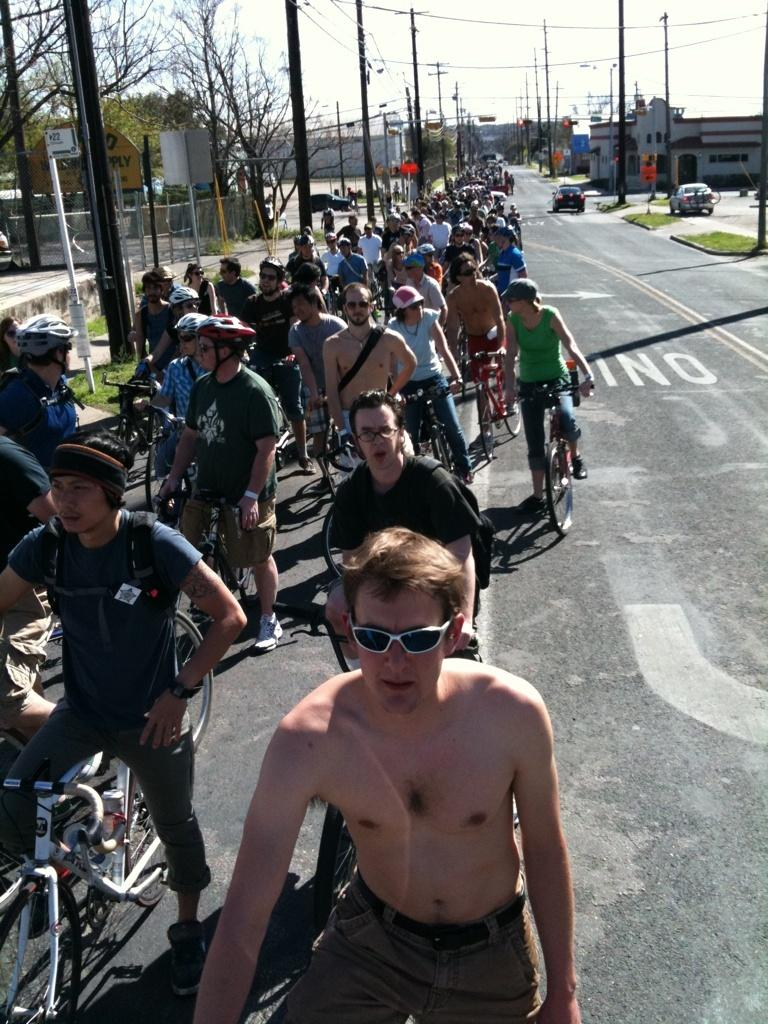How many people are in the image? There are people in the image, but the exact number is not specified. What are the people doing in the image? The people are standing and holding cycles in the image. What protective gear are the people wearing? The people are wearing goggles and helmets in the image. Where are the people standing? The people are standing on roads in the image. What can be seen in the background of the image? In the background of the image, there are cars, buildings, street lights, poles, and trees. What type of muscle is being flexed by the person in the image? There is no indication in the image that a person is flexing any muscles. What color is the yarn being used by the person in the image? There is no yarn present in the image. How many pears are visible in the image? There are no pears visible in the image. 